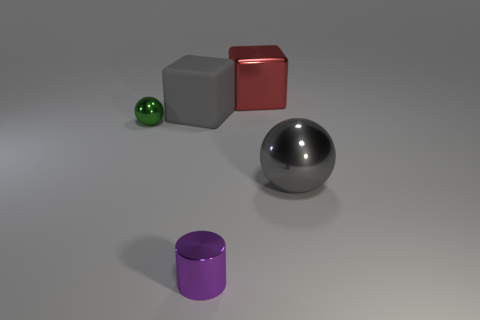Does the rubber block have the same color as the big ball?
Make the answer very short. Yes. What material is the large object that is in front of the big red cube and on the left side of the big gray ball?
Your response must be concise. Rubber. The large matte cube is what color?
Provide a short and direct response. Gray. Is the number of gray blocks that are to the right of the small cylinder less than the number of big red shiny things?
Keep it short and to the point. Yes. Is there anything else that is the same shape as the purple thing?
Offer a terse response. No. Are any blue cylinders visible?
Offer a very short reply. No. Are there fewer rubber cubes than large blue rubber cubes?
Offer a terse response. No. How many big balls are the same material as the purple thing?
Your answer should be very brief. 1. The other small object that is made of the same material as the tiny green object is what color?
Your answer should be compact. Purple. The small green metallic thing has what shape?
Your answer should be very brief. Sphere. 